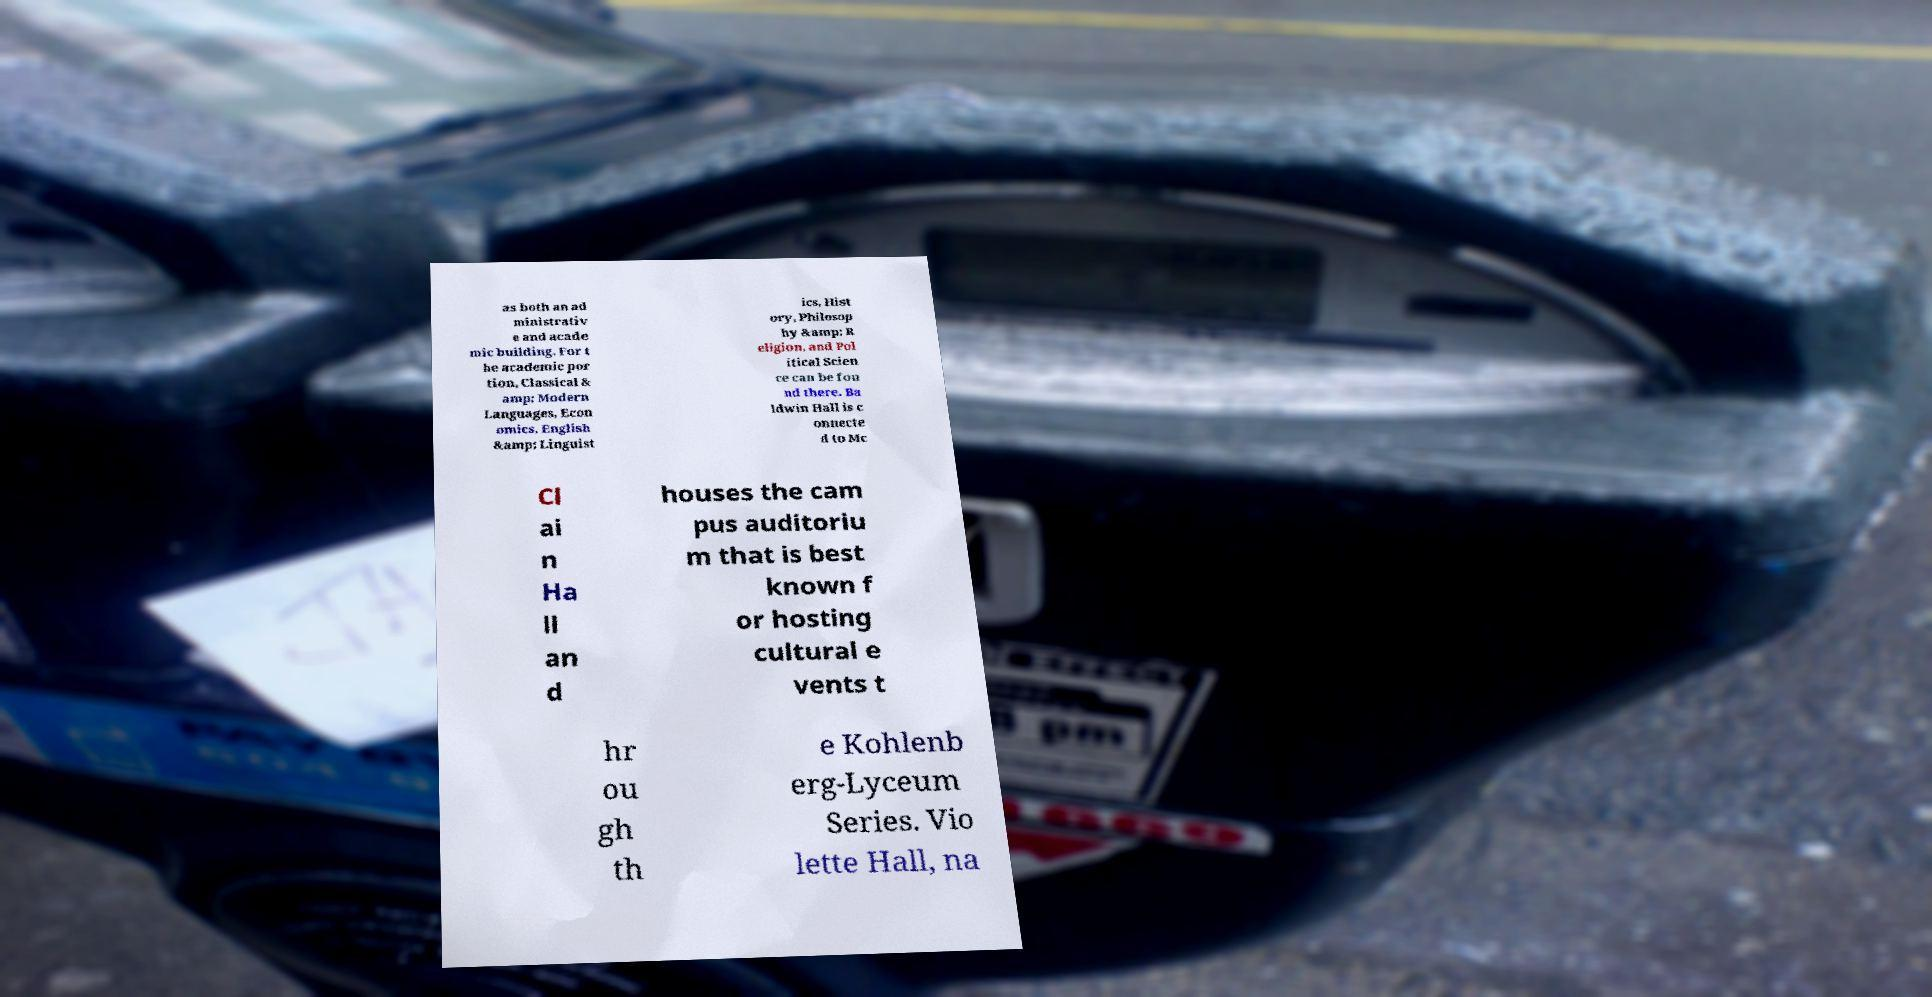Could you assist in decoding the text presented in this image and type it out clearly? as both an ad ministrativ e and acade mic building. For t he academic por tion, Classical & amp; Modern Languages, Econ omics, English &amp; Linguist ics, Hist ory, Philosop hy &amp; R eligion, and Pol itical Scien ce can be fou nd there. Ba ldwin Hall is c onnecte d to Mc Cl ai n Ha ll an d houses the cam pus auditoriu m that is best known f or hosting cultural e vents t hr ou gh th e Kohlenb erg-Lyceum Series. Vio lette Hall, na 